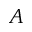Convert formula to latex. <formula><loc_0><loc_0><loc_500><loc_500>A</formula> 